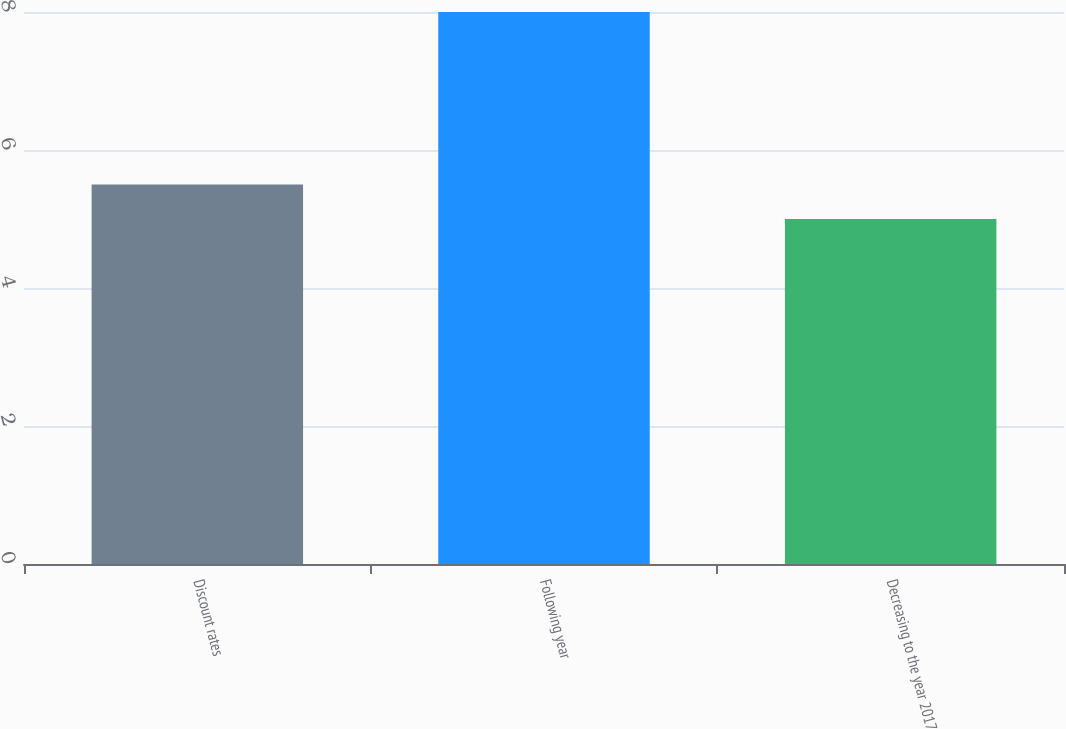Convert chart to OTSL. <chart><loc_0><loc_0><loc_500><loc_500><bar_chart><fcel>Discount rates<fcel>Following year<fcel>Decreasing to the year 2017<nl><fcel>5.5<fcel>8<fcel>5<nl></chart> 